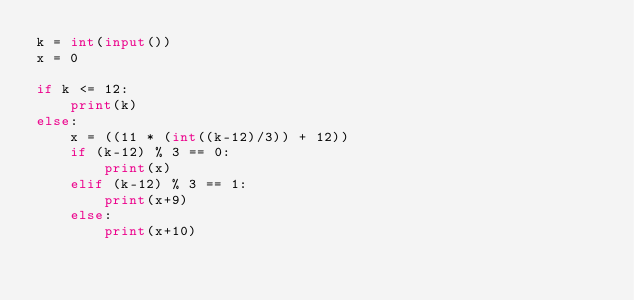Convert code to text. <code><loc_0><loc_0><loc_500><loc_500><_Python_>k = int(input())
x = 0

if k <= 12:
    print(k)
else:
    x = ((11 * (int((k-12)/3)) + 12))
    if (k-12) % 3 == 0:
        print(x)
    elif (k-12) % 3 == 1:
        print(x+9)
    else:
        print(x+10)</code> 